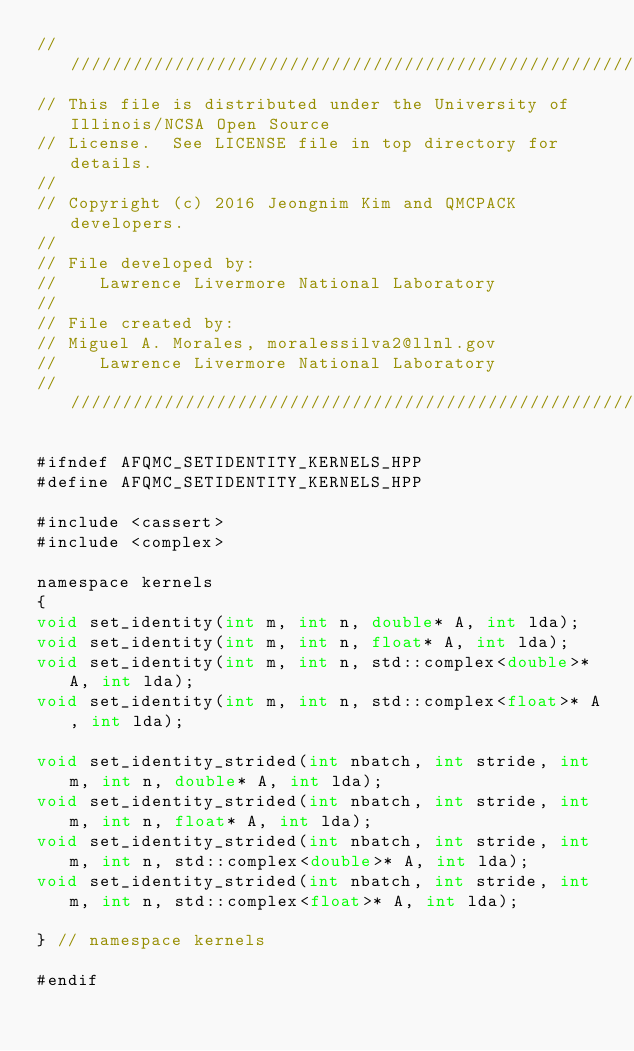Convert code to text. <code><loc_0><loc_0><loc_500><loc_500><_Cuda_>//////////////////////////////////////////////////////////////////////
// This file is distributed under the University of Illinois/NCSA Open Source
// License.  See LICENSE file in top directory for details.
//
// Copyright (c) 2016 Jeongnim Kim and QMCPACK developers.
//
// File developed by:
//    Lawrence Livermore National Laboratory
//
// File created by:
// Miguel A. Morales, moralessilva2@llnl.gov
//    Lawrence Livermore National Laboratory
////////////////////////////////////////////////////////////////////////////////

#ifndef AFQMC_SETIDENTITY_KERNELS_HPP
#define AFQMC_SETIDENTITY_KERNELS_HPP

#include <cassert>
#include <complex>

namespace kernels
{
void set_identity(int m, int n, double* A, int lda);
void set_identity(int m, int n, float* A, int lda);
void set_identity(int m, int n, std::complex<double>* A, int lda);
void set_identity(int m, int n, std::complex<float>* A, int lda);

void set_identity_strided(int nbatch, int stride, int m, int n, double* A, int lda);
void set_identity_strided(int nbatch, int stride, int m, int n, float* A, int lda);
void set_identity_strided(int nbatch, int stride, int m, int n, std::complex<double>* A, int lda);
void set_identity_strided(int nbatch, int stride, int m, int n, std::complex<float>* A, int lda);

} // namespace kernels

#endif
</code> 